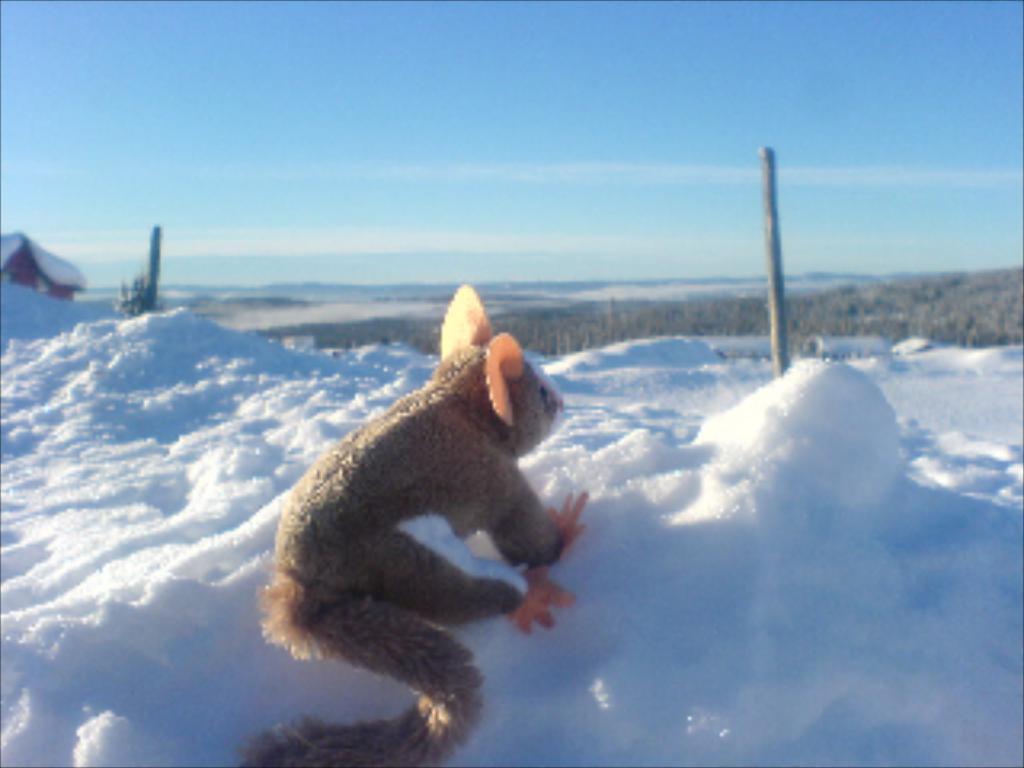Describe this image in one or two sentences. In the picture we can see a snow surface on it, we can see a doll which is in the kind of a rat and near it, we can see a pole and behind it, we can see trees, hills and sky with clouds and on the snow surface we can also see a house. 